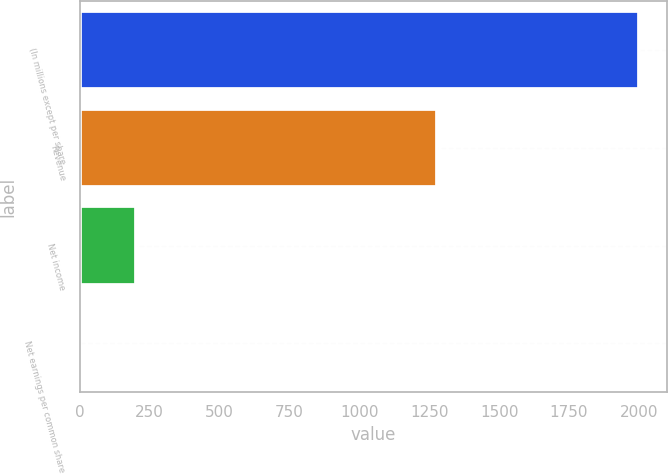Convert chart. <chart><loc_0><loc_0><loc_500><loc_500><bar_chart><fcel>(In millions except per share<fcel>Revenue<fcel>Net income<fcel>Net earnings per common share<nl><fcel>2000<fcel>1277<fcel>200.94<fcel>1.04<nl></chart> 